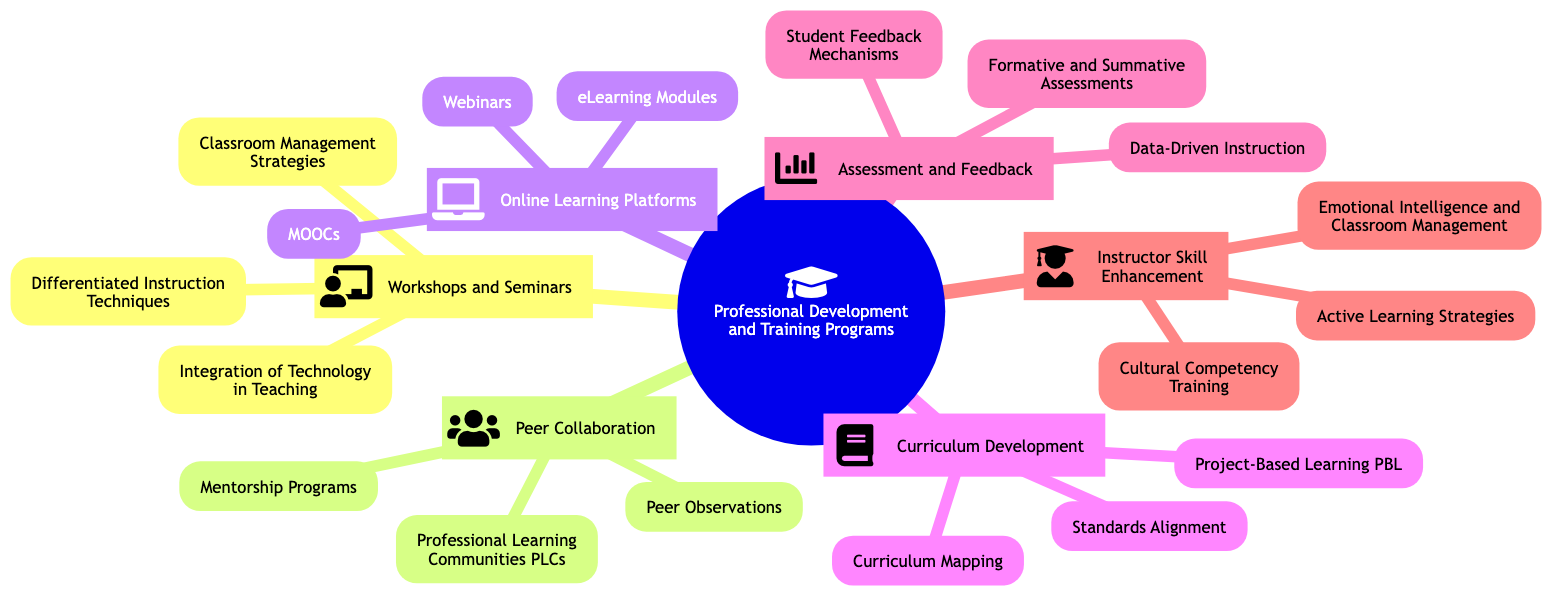What is the central topic of the diagram? The central topic is explicitly labeled as "Professional Development and Training Programs."
Answer: Professional Development and Training Programs How many subtopics are presented in the diagram? By counting the subtopics listed under the central topic, there are six: Workshops and Seminars, Peer Collaboration, Online Learning Platforms, Curriculum Development, Assessment and Feedback, and Instructor Skill Enhancement.
Answer: 6 Which subtopic includes "Data-Driven Instruction"? "Data-Driven Instruction" is a detail listed under the subtopic "Assessment and Feedback."
Answer: Assessment and Feedback What type of training does the "Instructor Skill Enhancement" subtopic focus on? This subtopic includes details about improving teaching skills through Active Learning Strategies, Cultural Competency Training, and Emotional Intelligence and Classroom Management, indicating a focus on enhancing instructional capabilities.
Answer: Instructor Skill Enhancement What is the relationship between "Peer Observations" and "Professional Learning Communities (PLCs)"? Both "Peer Observations" and "Professional Learning Communities (PLCs)" are part of the same subtopic "Peer Collaboration," indicating they are both strategies for collaboration among teachers.
Answer: Peer Collaboration How many details are provided in the "Curriculum Development" subtopic? The subtopic "Curriculum Development" contains three details: Curriculum Mapping, Standards Alignment, and Project-Based Learning (PBL), indicating the breadth of focus within that area.
Answer: 3 Which detail under "Online Learning Platforms" is characterized as a type of course format? "MOOCs (Massive Open Online Courses)" is indicated as a specific type of online course format provided under the "Online Learning Platforms" subtopic.
Answer: MOOCs What common theme is shared among the details in the "Workshops and Seminars" subtopic? The details in the "Workshops and Seminars" subtopic focus on improving various instructional techniques, such as Classroom Management Strategies, Differentiated Instruction Techniques, and Integration of Technology in Teaching, highlighting a theme of instructional effectiveness.
Answer: Instructional Techniques Which subtopic contains "Emotional Intelligence and Classroom Emotional Management"? "Emotional Intelligence and Classroom Emotional Management" is found under the "Instructor Skill Enhancement" subtopic as one of its detail areas.
Answer: Instructor Skill Enhancement 